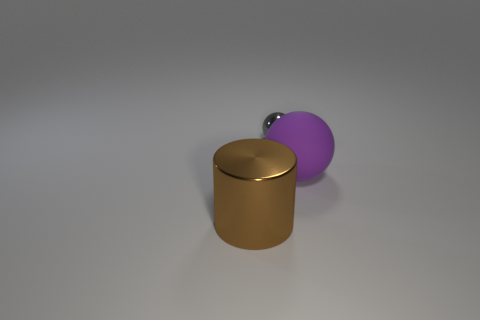Is the size of the brown metal object the same as the rubber sphere? Based on visual observation, the brown metal object appears similar in size compared to the purple rubber sphere, although it's difficult to determine exact dimensions from this angle. The objects share comparable dimensions but without precise measurement, we can't conclude they are exactly the same size. 